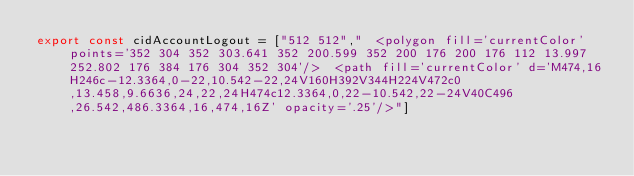<code> <loc_0><loc_0><loc_500><loc_500><_JavaScript_>export const cidAccountLogout = ["512 512","  <polygon fill='currentColor' points='352 304 352 303.641 352 200.599 352 200 176 200 176 112 13.997 252.802 176 384 176 304 352 304'/>  <path fill='currentColor' d='M474,16H246c-12.3364,0-22,10.542-22,24V160H392V344H224V472c0,13.458,9.6636,24,22,24H474c12.3364,0,22-10.542,22-24V40C496,26.542,486.3364,16,474,16Z' opacity='.25'/>"]</code> 